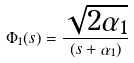Convert formula to latex. <formula><loc_0><loc_0><loc_500><loc_500>\Phi _ { 1 } ( s ) = \frac { \sqrt { 2 \alpha _ { 1 } } } { ( s + \alpha _ { 1 } ) }</formula> 